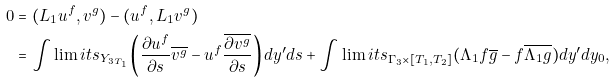Convert formula to latex. <formula><loc_0><loc_0><loc_500><loc_500>0 & = ( L _ { 1 } u ^ { f } , v ^ { g } ) - ( u ^ { f } , L _ { 1 } v ^ { g } ) \\ & = \int \lim i t s _ { Y _ { 3 T _ { 1 } } } \left ( \frac { \partial u ^ { f } } { \partial s } \overline { v ^ { g } } - u ^ { f } \frac { \overline { \partial v ^ { g } } } { \partial s } \right ) d y ^ { \prime } d s + \int \lim i t s _ { \Gamma _ { 3 } \times [ T _ { 1 } , T _ { 2 } ] } ( \Lambda _ { 1 } f \overline { g } - f \overline { \Lambda _ { 1 } g } ) d y ^ { \prime } d y _ { 0 } ,</formula> 